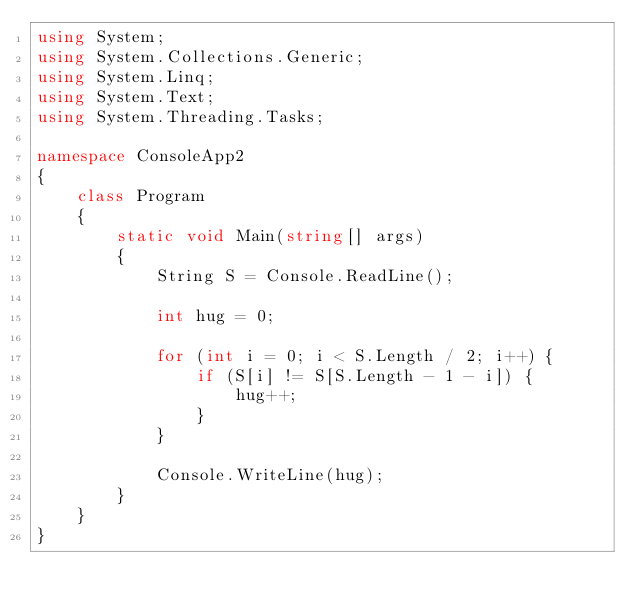Convert code to text. <code><loc_0><loc_0><loc_500><loc_500><_C#_>using System;
using System.Collections.Generic;
using System.Linq;
using System.Text;
using System.Threading.Tasks;

namespace ConsoleApp2
{
    class Program
    {
        static void Main(string[] args)
        {
            String S = Console.ReadLine();

            int hug = 0;

            for (int i = 0; i < S.Length / 2; i++) {
                if (S[i] != S[S.Length - 1 - i]) {
                    hug++;
                }
            }

            Console.WriteLine(hug);
        }
    }
}
</code> 